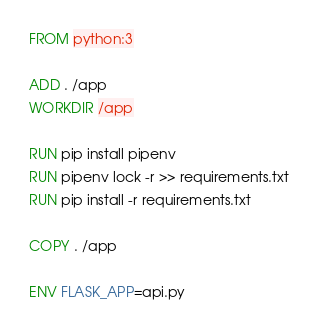<code> <loc_0><loc_0><loc_500><loc_500><_Dockerfile_>FROM python:3

ADD . /app
WORKDIR /app

RUN pip install pipenv
RUN pipenv lock -r >> requirements.txt
RUN pip install -r requirements.txt

COPY . /app

ENV FLASK_APP=api.py</code> 